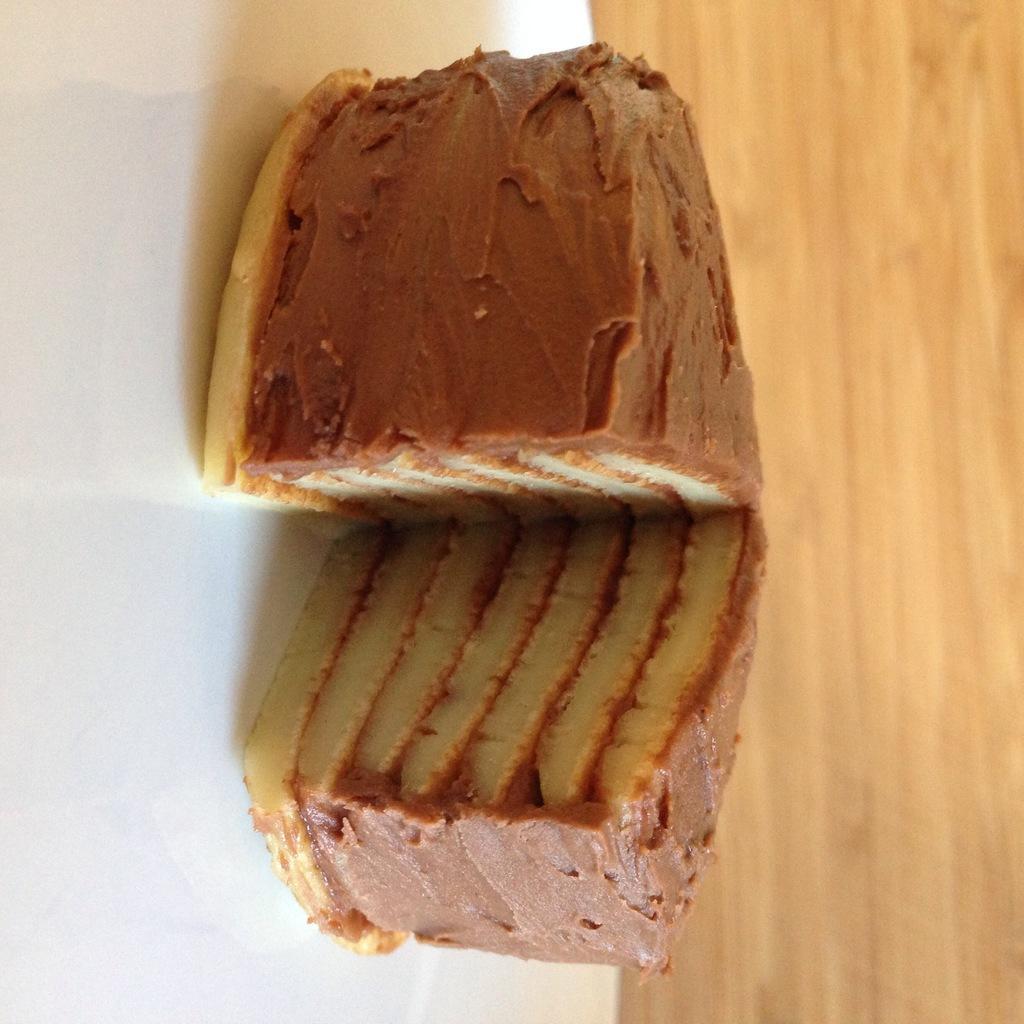Could you give a brief overview of what you see in this image? In this picture we can see some food is present in a plate, at the bottom there is a wooden surface. 